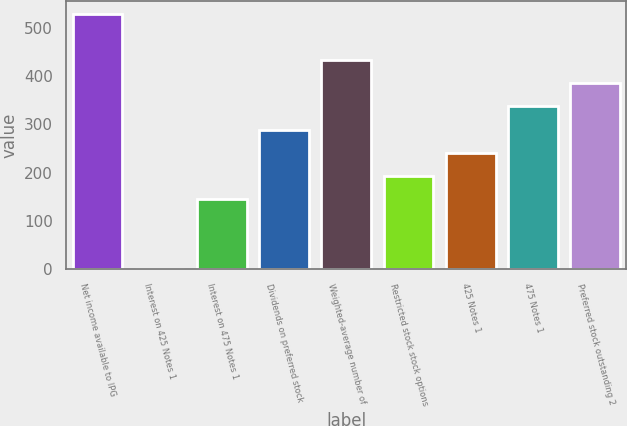<chart> <loc_0><loc_0><loc_500><loc_500><bar_chart><fcel>Net income available to IPG<fcel>Interest on 425 Notes 1<fcel>Interest on 475 Notes 1<fcel>Dividends on preferred stock<fcel>Weighted-average number of<fcel>Restricted stock stock options<fcel>425 Notes 1<fcel>475 Notes 1<fcel>Preferred stock outstanding 2<nl><fcel>529.51<fcel>0.3<fcel>144.63<fcel>288.96<fcel>433.29<fcel>192.74<fcel>240.85<fcel>337.07<fcel>385.18<nl></chart> 